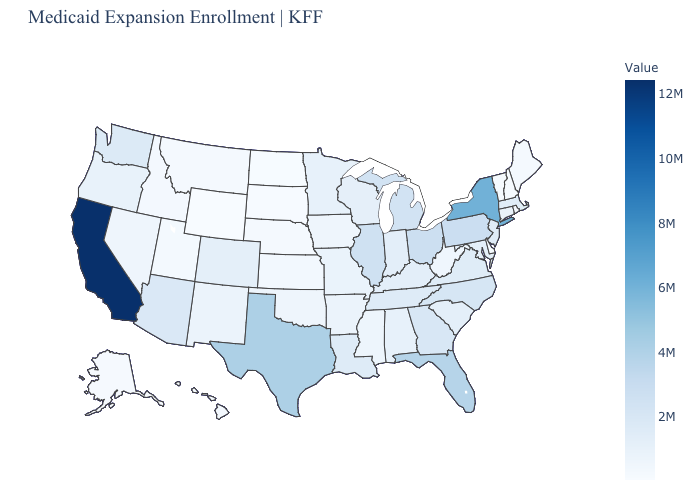Among the states that border Nevada , which have the lowest value?
Quick response, please. Utah. Which states have the lowest value in the USA?
Short answer required. Wyoming. Does the map have missing data?
Be succinct. No. Which states have the lowest value in the Northeast?
Concise answer only. Vermont. Does Connecticut have the highest value in the USA?
Concise answer only. No. Does Hawaii have the highest value in the West?
Answer briefly. No. Does California have the highest value in the West?
Write a very short answer. Yes. 